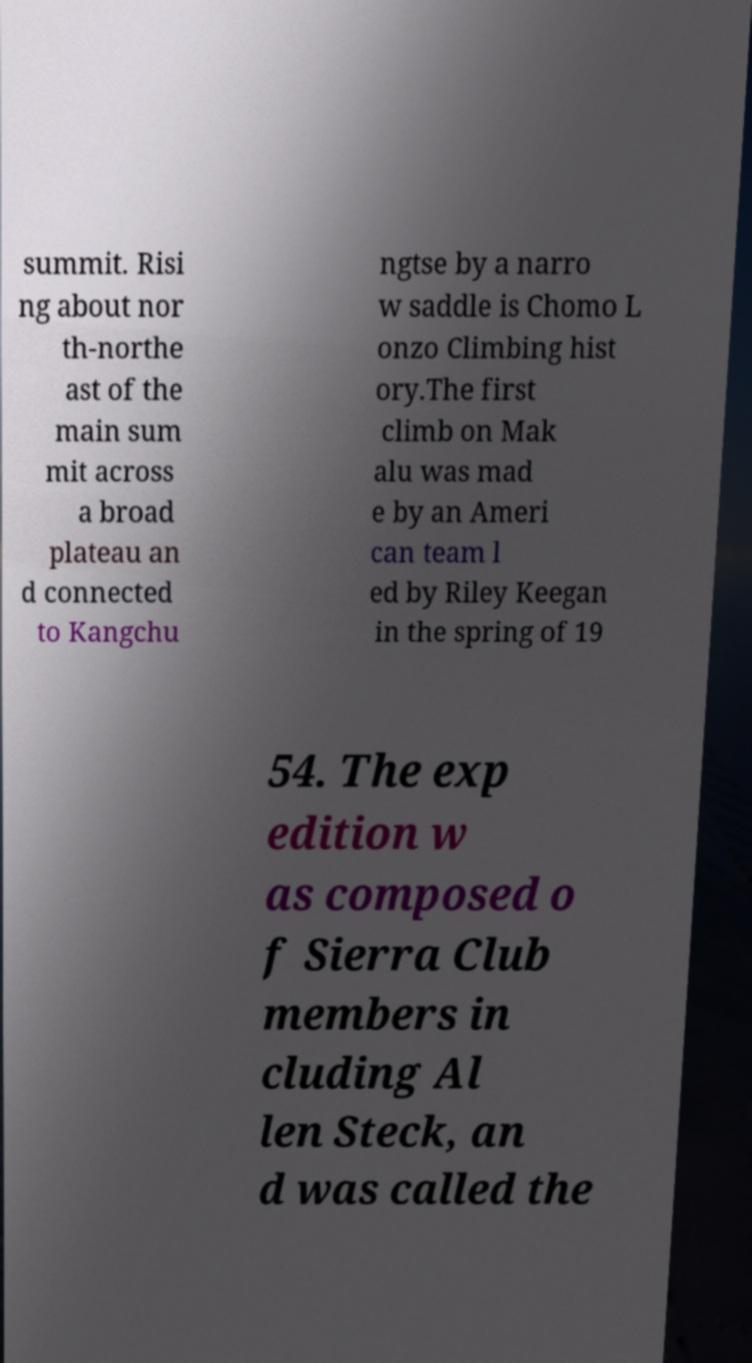There's text embedded in this image that I need extracted. Can you transcribe it verbatim? summit. Risi ng about nor th-northe ast of the main sum mit across a broad plateau an d connected to Kangchu ngtse by a narro w saddle is Chomo L onzo Climbing hist ory.The first climb on Mak alu was mad e by an Ameri can team l ed by Riley Keegan in the spring of 19 54. The exp edition w as composed o f Sierra Club members in cluding Al len Steck, an d was called the 